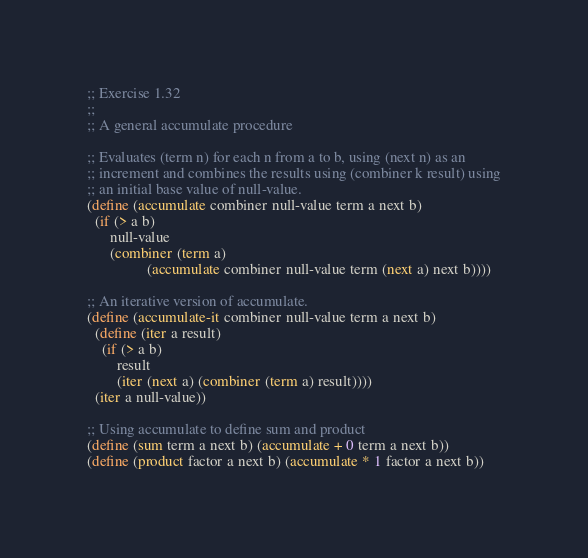Convert code to text. <code><loc_0><loc_0><loc_500><loc_500><_Scheme_>;; Exercise 1.32
;;
;; A general accumulate procedure

;; Evaluates (term n) for each n from a to b, using (next n) as an
;; increment and combines the results using (combiner k result) using
;; an initial base value of null-value.
(define (accumulate combiner null-value term a next b)
  (if (> a b)
      null-value
      (combiner (term a)
                (accumulate combiner null-value term (next a) next b))))

;; An iterative version of accumulate.
(define (accumulate-it combiner null-value term a next b)
  (define (iter a result)
    (if (> a b)
        result
        (iter (next a) (combiner (term a) result))))
  (iter a null-value))

;; Using accumulate to define sum and product
(define (sum term a next b) (accumulate + 0 term a next b))
(define (product factor a next b) (accumulate * 1 factor a next b))
</code> 